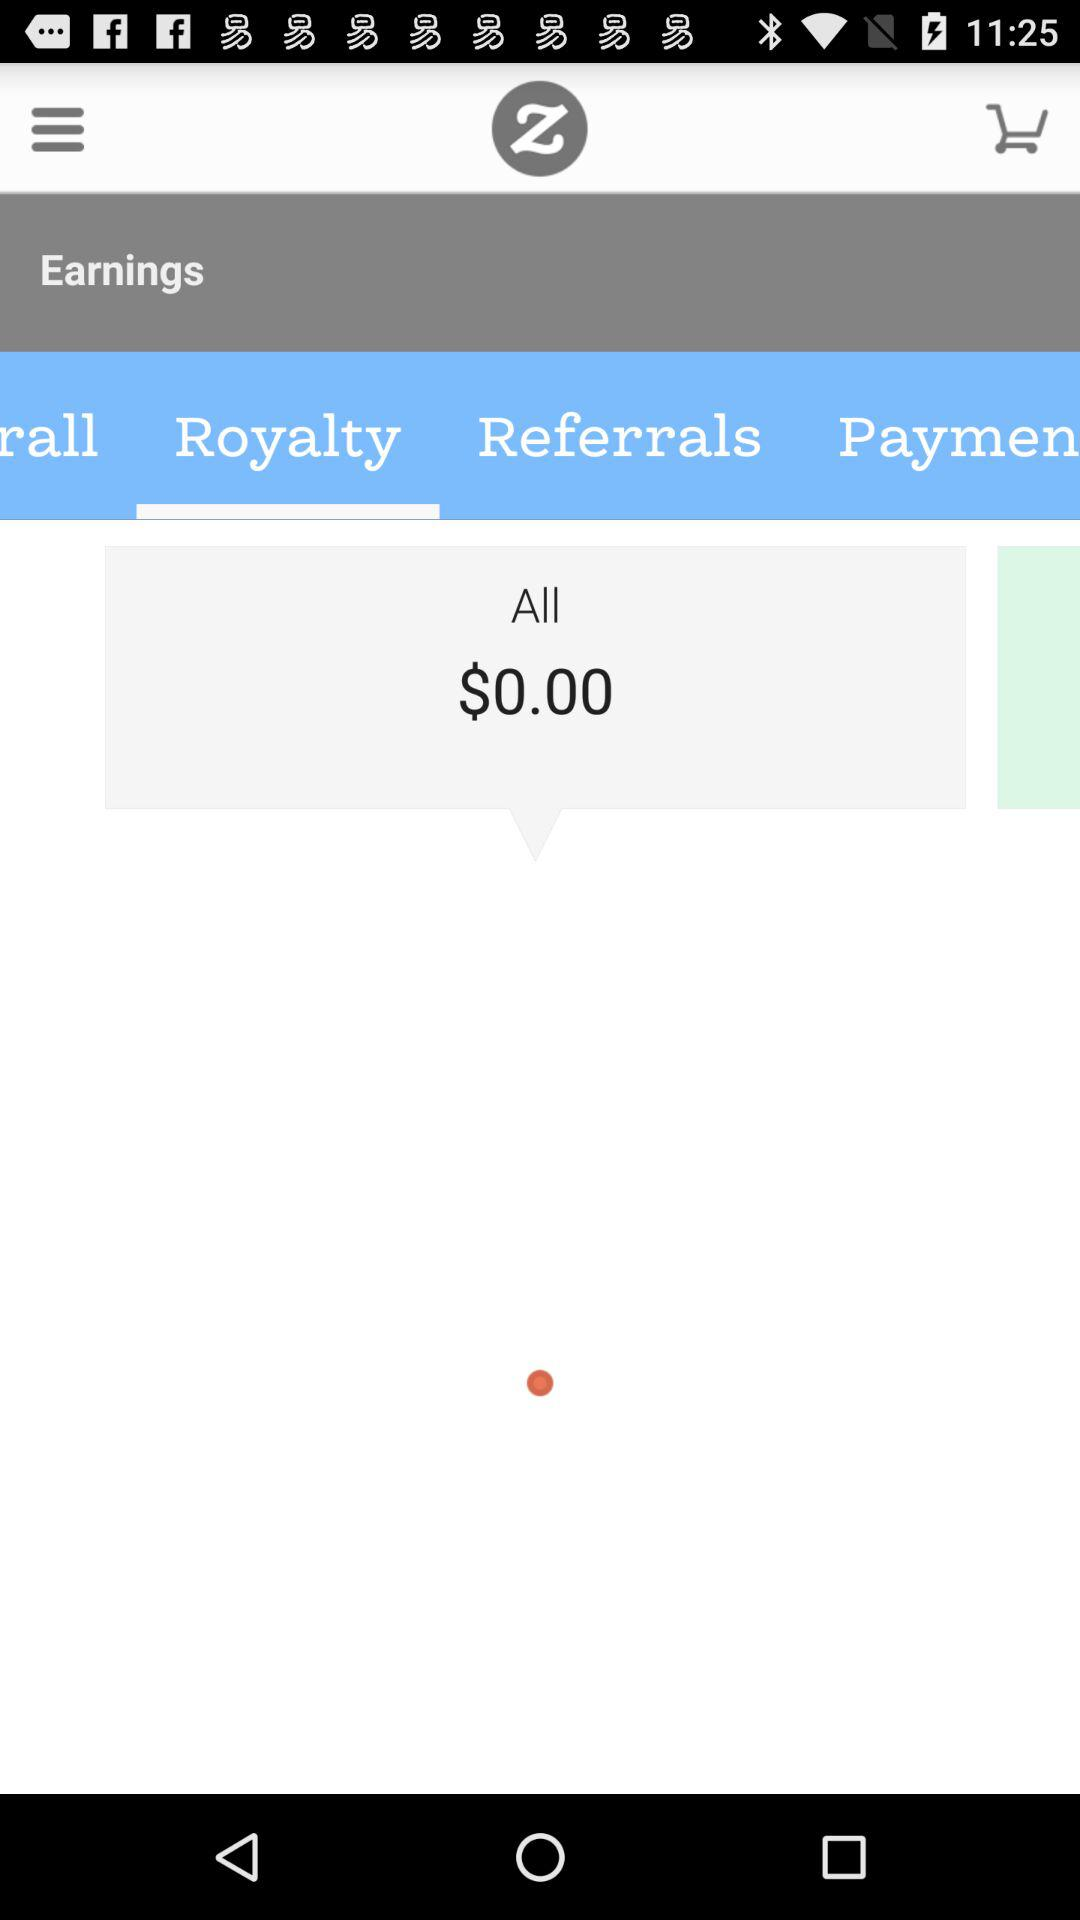How much do I earn in total?
Answer the question using a single word or phrase. $0.00 